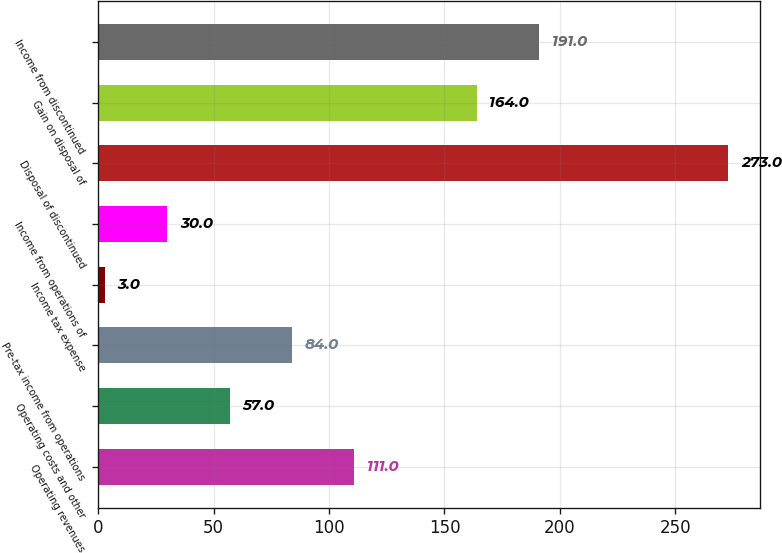Convert chart. <chart><loc_0><loc_0><loc_500><loc_500><bar_chart><fcel>Operating revenues<fcel>Operating costs and other<fcel>Pre-tax income from operations<fcel>Income tax expense<fcel>Income from operations of<fcel>Disposal of discontinued<fcel>Gain on disposal of<fcel>Income from discontinued<nl><fcel>111<fcel>57<fcel>84<fcel>3<fcel>30<fcel>273<fcel>164<fcel>191<nl></chart> 